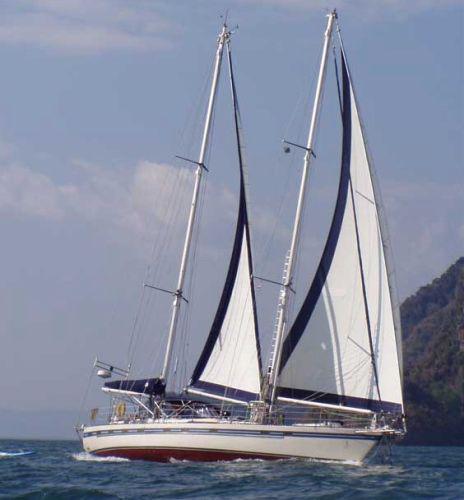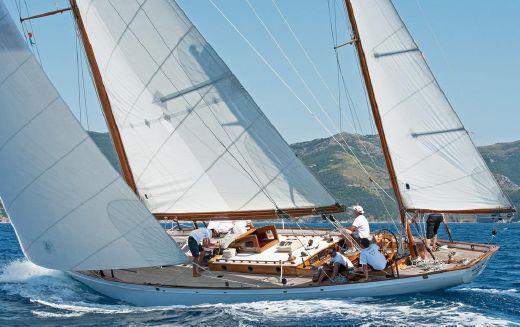The first image is the image on the left, the second image is the image on the right. Examine the images to the left and right. Is the description "the sailboat has no more than 3 sails" accurate? Answer yes or no. Yes. The first image is the image on the left, the second image is the image on the right. Considering the images on both sides, is "One boat has more than 3 sails" valid? Answer yes or no. No. 